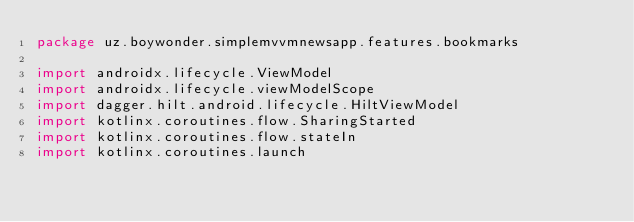<code> <loc_0><loc_0><loc_500><loc_500><_Kotlin_>package uz.boywonder.simplemvvmnewsapp.features.bookmarks

import androidx.lifecycle.ViewModel
import androidx.lifecycle.viewModelScope
import dagger.hilt.android.lifecycle.HiltViewModel
import kotlinx.coroutines.flow.SharingStarted
import kotlinx.coroutines.flow.stateIn
import kotlinx.coroutines.launch</code> 